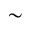Convert formula to latex. <formula><loc_0><loc_0><loc_500><loc_500>\sim</formula> 